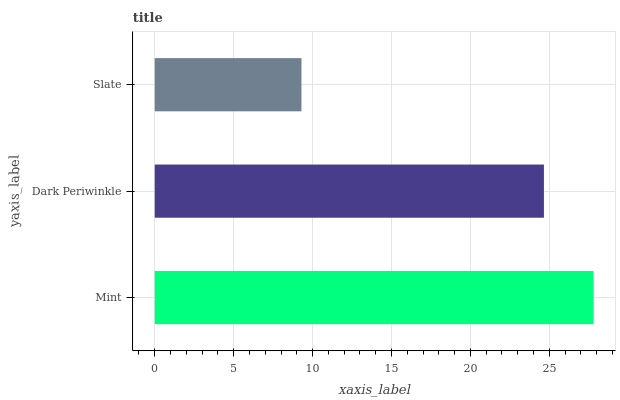Is Slate the minimum?
Answer yes or no. Yes. Is Mint the maximum?
Answer yes or no. Yes. Is Dark Periwinkle the minimum?
Answer yes or no. No. Is Dark Periwinkle the maximum?
Answer yes or no. No. Is Mint greater than Dark Periwinkle?
Answer yes or no. Yes. Is Dark Periwinkle less than Mint?
Answer yes or no. Yes. Is Dark Periwinkle greater than Mint?
Answer yes or no. No. Is Mint less than Dark Periwinkle?
Answer yes or no. No. Is Dark Periwinkle the high median?
Answer yes or no. Yes. Is Dark Periwinkle the low median?
Answer yes or no. Yes. Is Slate the high median?
Answer yes or no. No. Is Slate the low median?
Answer yes or no. No. 